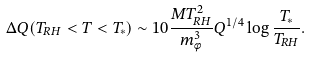Convert formula to latex. <formula><loc_0><loc_0><loc_500><loc_500>\Delta Q ( T _ { R H } < T < T _ { * } ) \sim 1 0 \frac { M T _ { R H } ^ { 2 } } { m _ { \phi } ^ { 3 } } Q ^ { 1 / 4 } \log \frac { T _ { * } } { T _ { R H } } .</formula> 